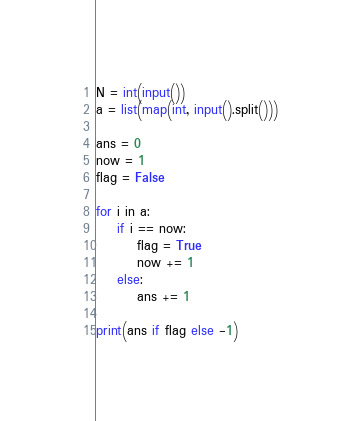<code> <loc_0><loc_0><loc_500><loc_500><_Python_>N = int(input())
a = list(map(int, input().split()))

ans = 0
now = 1
flag = False

for i in a:
    if i == now:
        flag = True
        now += 1
    else:
        ans += 1
        
print(ans if flag else -1)</code> 